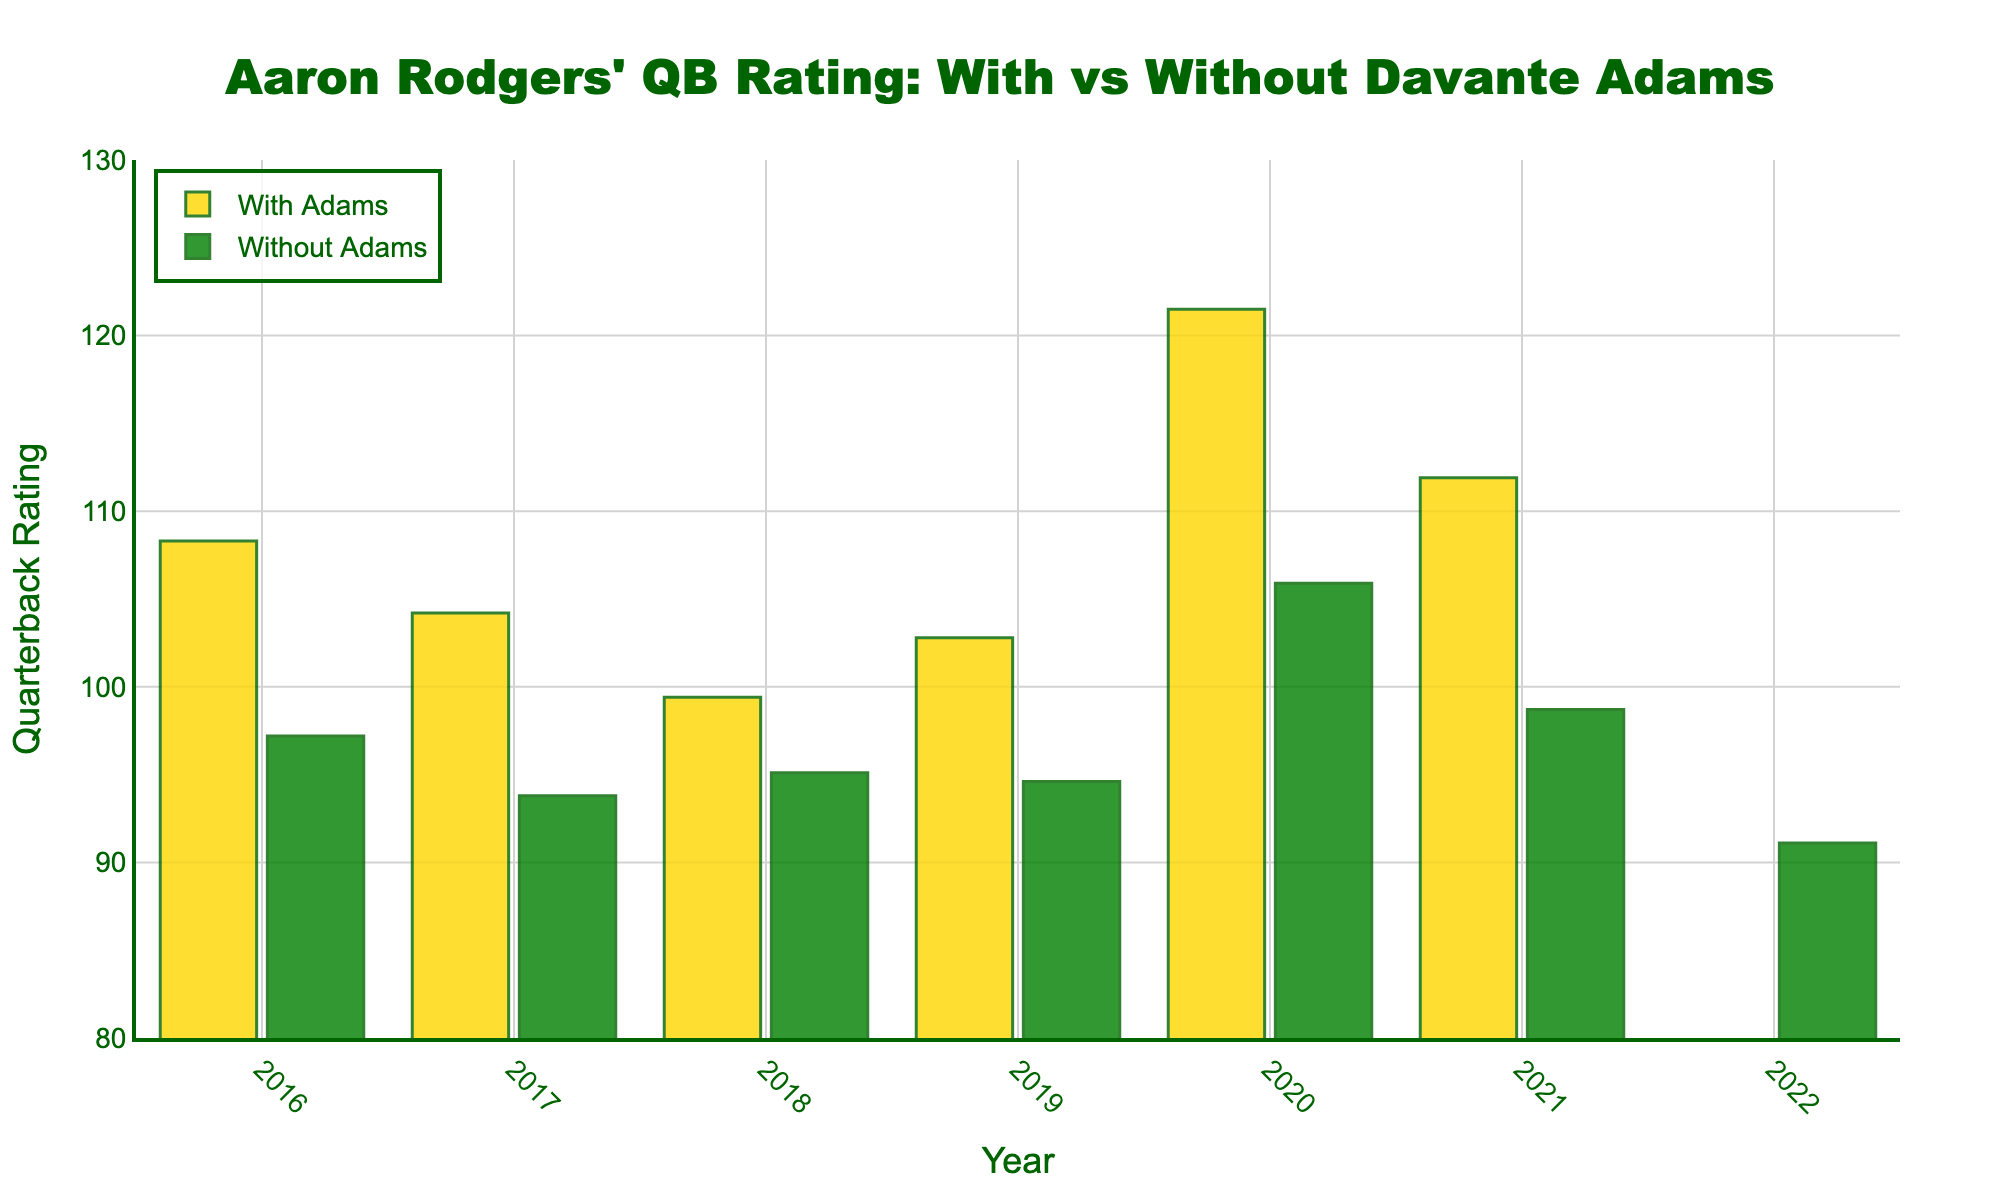What is Aaron Rodgers' quarterback rating with Davante Adams on the field in 2020? Look at the bar labeled 'With Adams' for the year 2020.
Answer: 121.5 What is the difference in Aaron Rodgers' quarterback rating between 2020 and 2018 without Davante Adams? Find the ratings for both years in the 'Without Adams' category and subtract the 2018 rating from the 2020 rating. 105.9 (2020) - 95.1 (2018) = 10.8
Answer: 10.8 Which year had the highest quarterback rating for Aaron Rodgers with Davante Adams? Compare all the bars labeled 'With Adams' and identify the tallest one, which represents the highest rating.
Answer: 2020 In 2021, how does Aaron Rodgers' quarterback rating compare with and without Davante Adams? Look at the heights of the bars for 2021 and compare their values. 111.9 (With Adams) vs. 98.7 (Without Adams).
Answer: Higher with Adams By how many points did Aaron Rodgers' quarterback rating drop from 2021 to 2022 without Davante Adams? Subtract the 2022 rating from the 2021 rating in the 'Without Adams' category. 98.7 (2021) - 91.1 (2022) = 7.6
Answer: 7.6 On average, was Aaron Rodgers’ rating higher with or without Davante Adams between 2016 and 2021? Calculate the average rating for both categories from 2016 to 2021 and compare them. Average (With Adams) = (108.3 + 104.2 + 99.4 + 102.8 + 121.5 + 111.9)/6 = 108.02; Average (Without Adams) = (97.2 + 93.8 + 95.1 + 94.6 + 105.9 + 98.7)/6 = 97.55
Answer: Higher with Adams Which year shows the smallest difference in quarterback rating with and without Davante Adams? Calculate the difference for each year and find the smallest one.
Answer: 2018 (4.3) In how many years was Aaron Rodgers' quarterback rating higher without Davante Adams compared to with him, between 2016-2022? Count the years where the 'Without Adams' bar is taller than the 'With Adams' bar.
Answer: 0 What is the overall range of Aaron Rodgers' quarterback ratings with Davante Adams between 2016 and 2021? Find the highest rating and the lowest rating with Davante Adams and subtract the two. Highest: 121.5 (2020), Lowest: 99.4 (2018). 121.5 - 99.4 = 22.1
Answer: 22.1 What is the color difference between the bars representing ratings with Adams and without Adams? Identify the colors used for each category.
Answer: With Adams: gold, Without Adams: green 